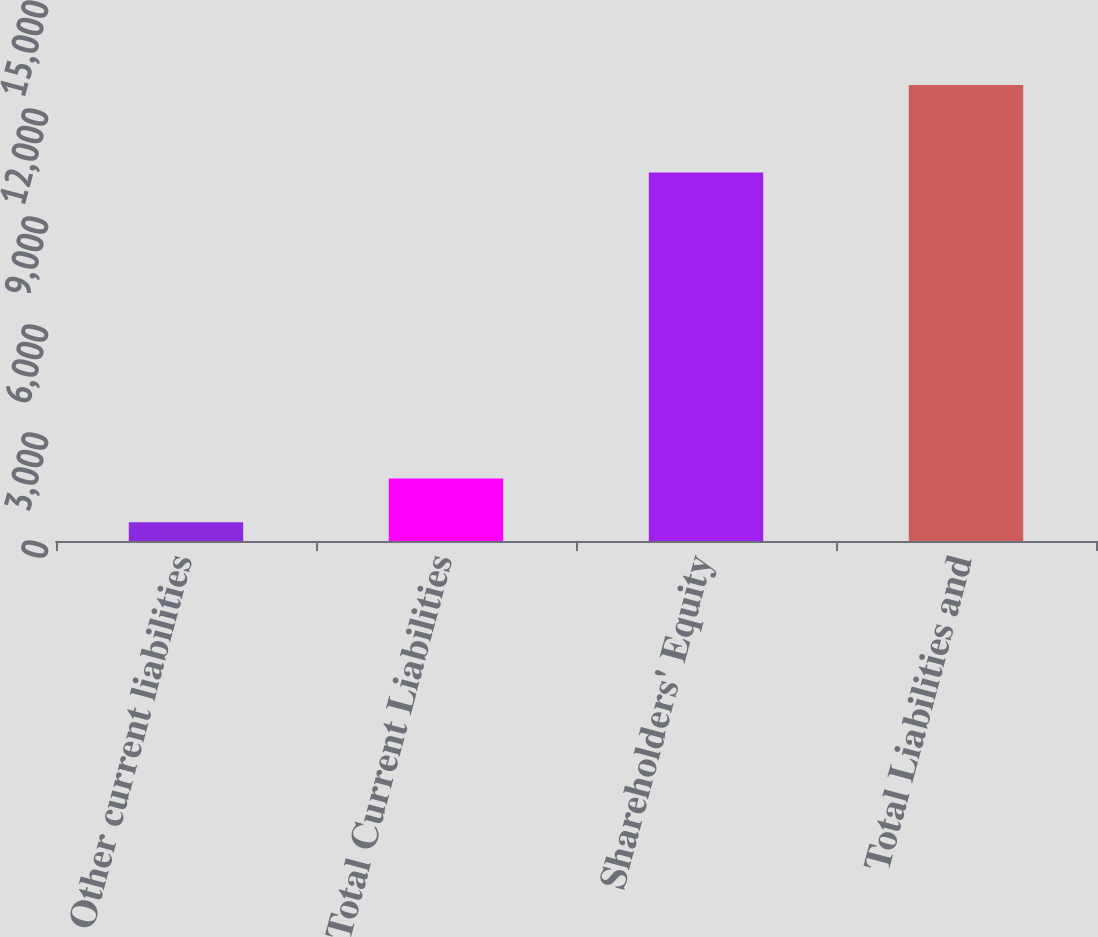Convert chart. <chart><loc_0><loc_0><loc_500><loc_500><bar_chart><fcel>Other current liabilities<fcel>Total Current Liabilities<fcel>Shareholders' Equity<fcel>Total Liabilities and<nl><fcel>523<fcel>1737.6<fcel>10233<fcel>12669<nl></chart> 